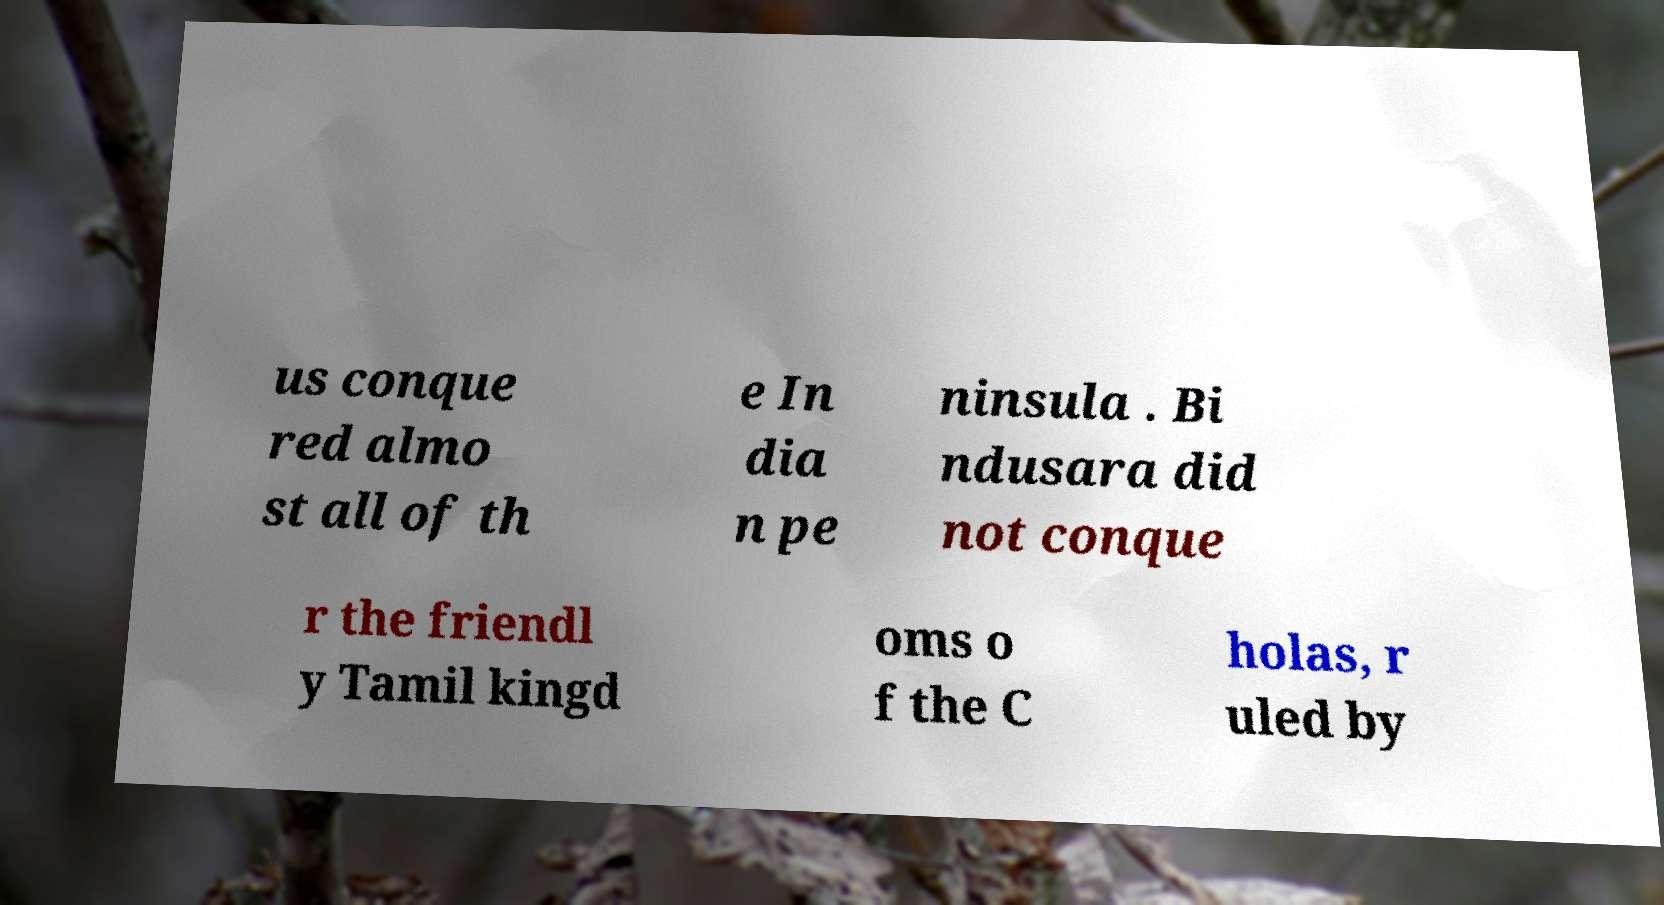Please read and relay the text visible in this image. What does it say? us conque red almo st all of th e In dia n pe ninsula . Bi ndusara did not conque r the friendl y Tamil kingd oms o f the C holas, r uled by 